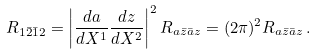<formula> <loc_0><loc_0><loc_500><loc_500>R _ { 1 \bar { 2 } \bar { 1 } 2 } = \left | \frac { d a } { d X ^ { 1 } } \frac { d z } { d X ^ { 2 } } \right | ^ { 2 } R _ { a \bar { z } \bar { a } z } = ( 2 \pi ) ^ { 2 } R _ { a \bar { z } \bar { a } z } \, .</formula> 